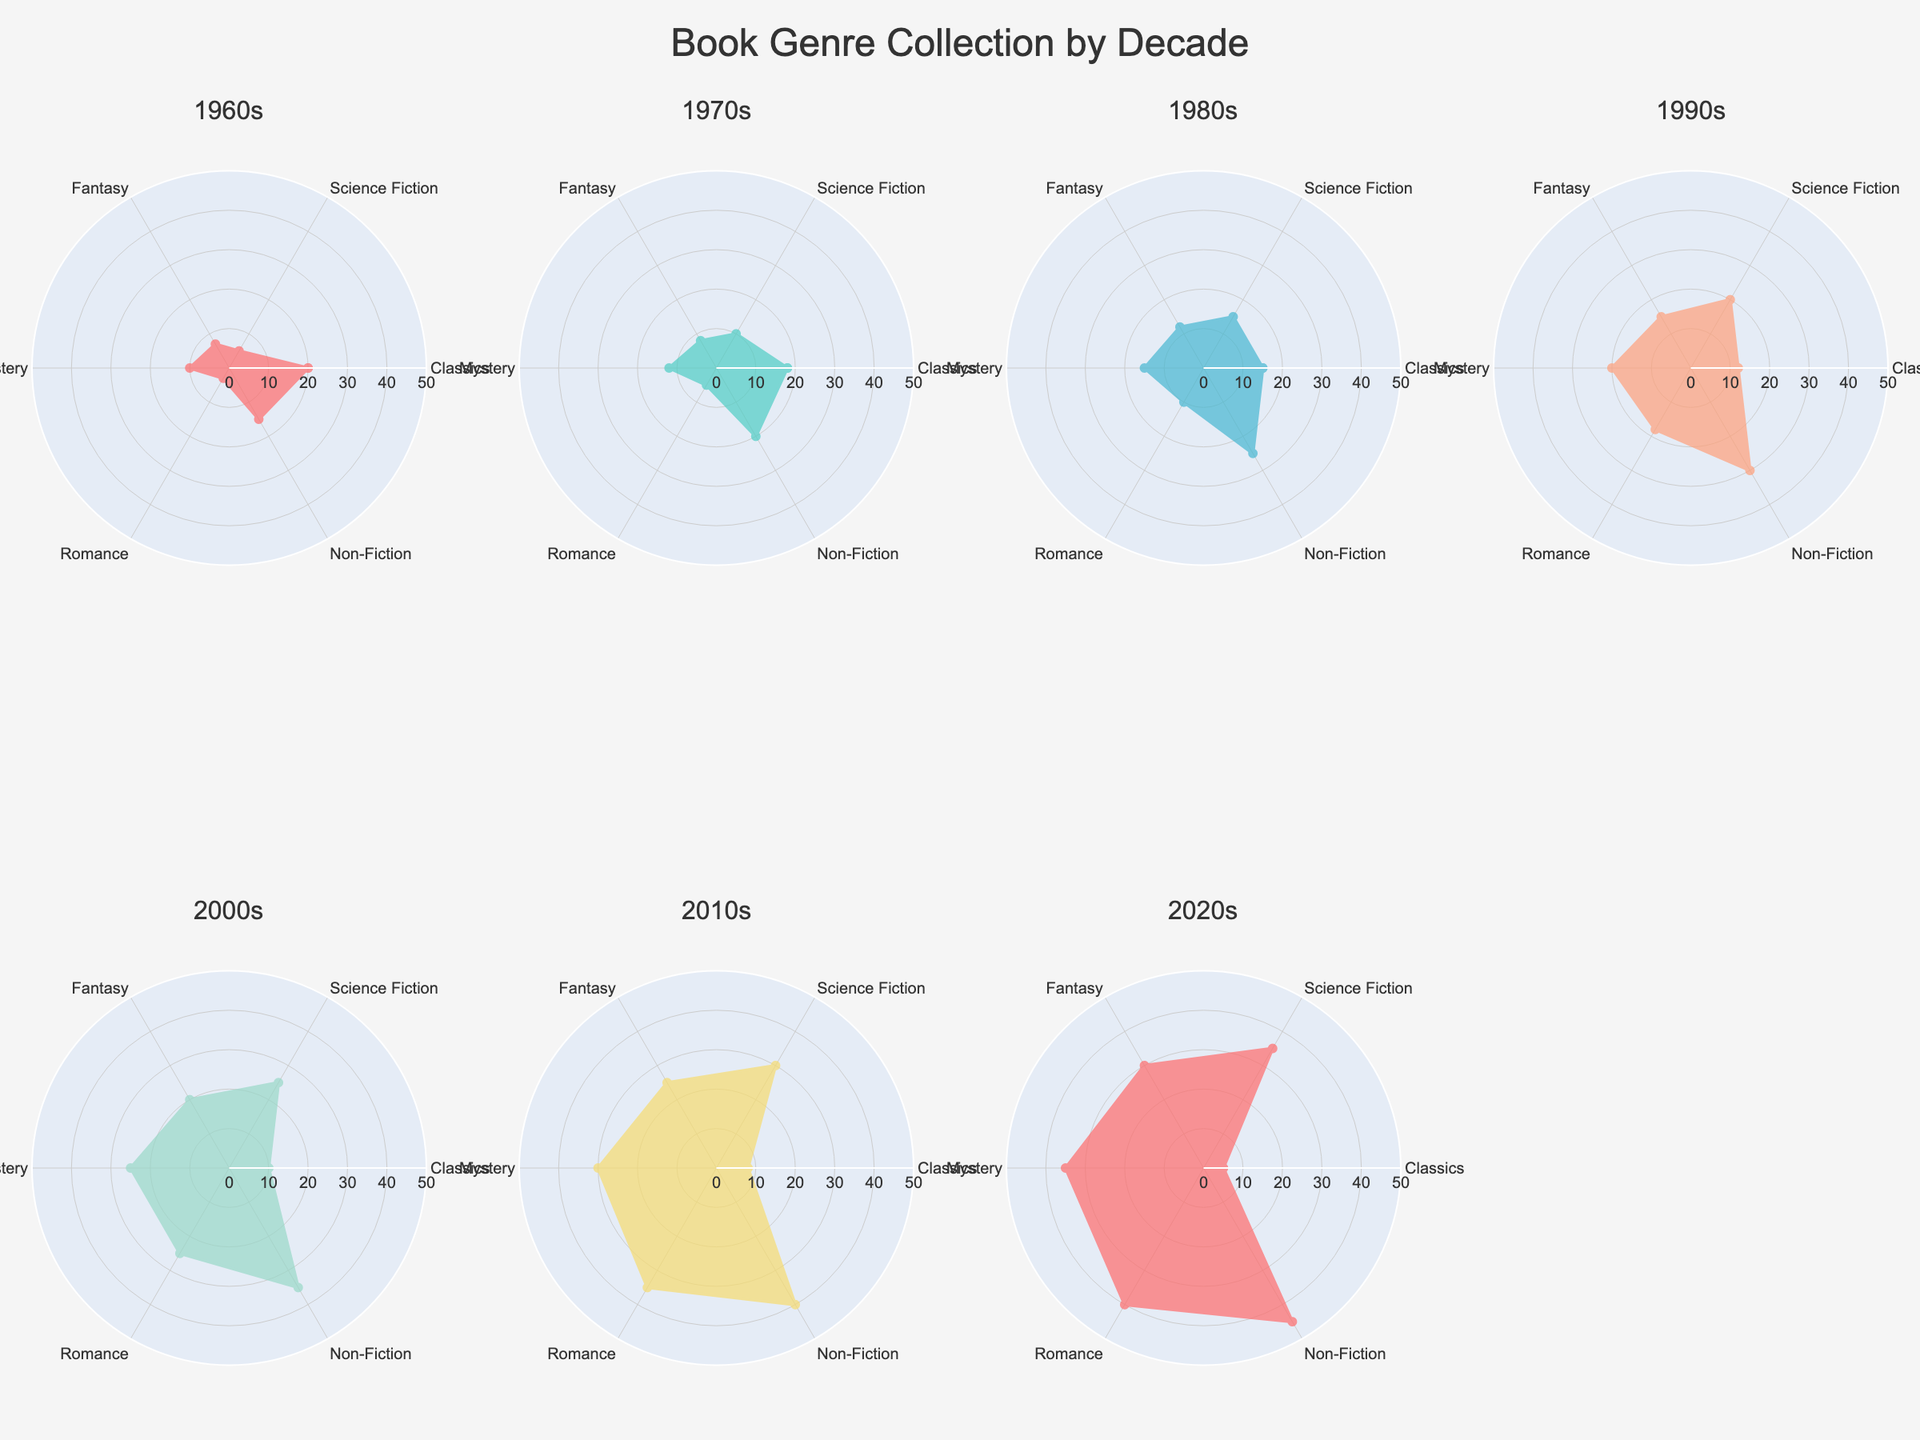Which decade saw the highest number of Science Fiction books collected? By looking at the radar charts for each decade, identify the highest point on the Science Fiction axis. The 2020s display the highest value in the Science Fiction category.
Answer: 2020s Which genres increased in collection across every decade from the 1960s to the 2020s? Assess the values for each genre in all decades. Genres that consistently show an upward trend across all radar subplots are Science Fiction, Fantasy, Mystery, Romance, and Non-Fiction.
Answer: Science Fiction, Fantasy, Mystery, Romance, Non-Fiction What's the average number of Classics collected for the decades from 1960s to 2020s? Sum the number of Classics collected for each decade (20+18+15+12+10+8+5 = 88) and divide by the number of decades (7): 88/7 = 12.57.
Answer: 12.57 In which decade did Non-Fiction books see the largest increase compared to the previous decade? Compare the difference in Non-Fiction collection numbers between consecutive decades. The largest difference is between the 2010s (40) and 2020s (45), which is an increase of 5.
Answer: 2020s Did the collection of Fantasy books ever decrease compared to the previous decade? Review the values on the radar charts for Fantasy books in each decade. There are no consecutive decades where the number of Fantasy books decreases; it shows only an increasing trend.
Answer: No Which genre was least collected in the 1960s? Observe the values and the radar subplot for the 1960s and identify the lowest point. The Romance genre is the least collected with only 3 books.
Answer: Romance On average, how many Romance books were collected per decade? Sum the number of Romance books collected each decade (3+5+10+18+25+35+40 = 136), then divide by the number of decades (7): 136/7 = 19.43.
Answer: 19.43 In which decade did the Mystery genre surpass the Classics genre for the first time? Compare the Mystery and Classics points for each decade. In the 1980s, Mystery (15) surpasses Classics (15) for the first time.
Answer: 1980s Which decade had the most balanced collection across all six genres? Analyze the radar chart for the decade where the data points on the radar are the most evenly distributed across the six genres. The 1980s show the most balanced collection with least variation among genre values.
Answer: 1980s 